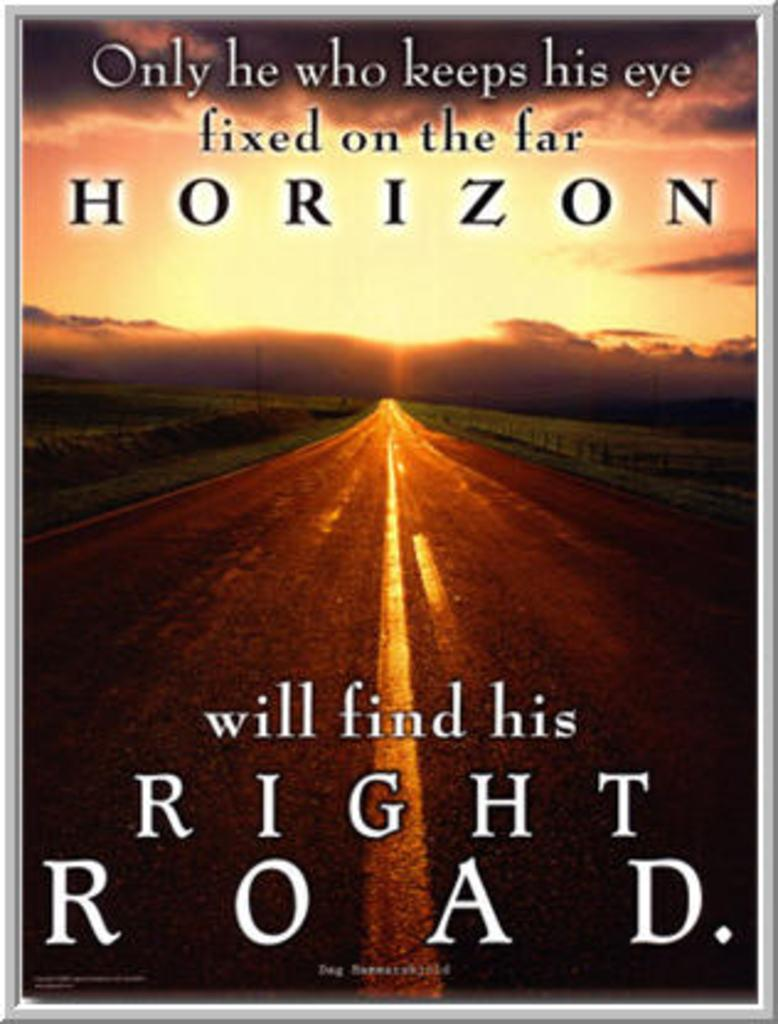<image>
Render a clear and concise summary of the photo. Poster featuring a road and a sunset with the text that hreads onley he who keeps his eye fixed on the horizon. 